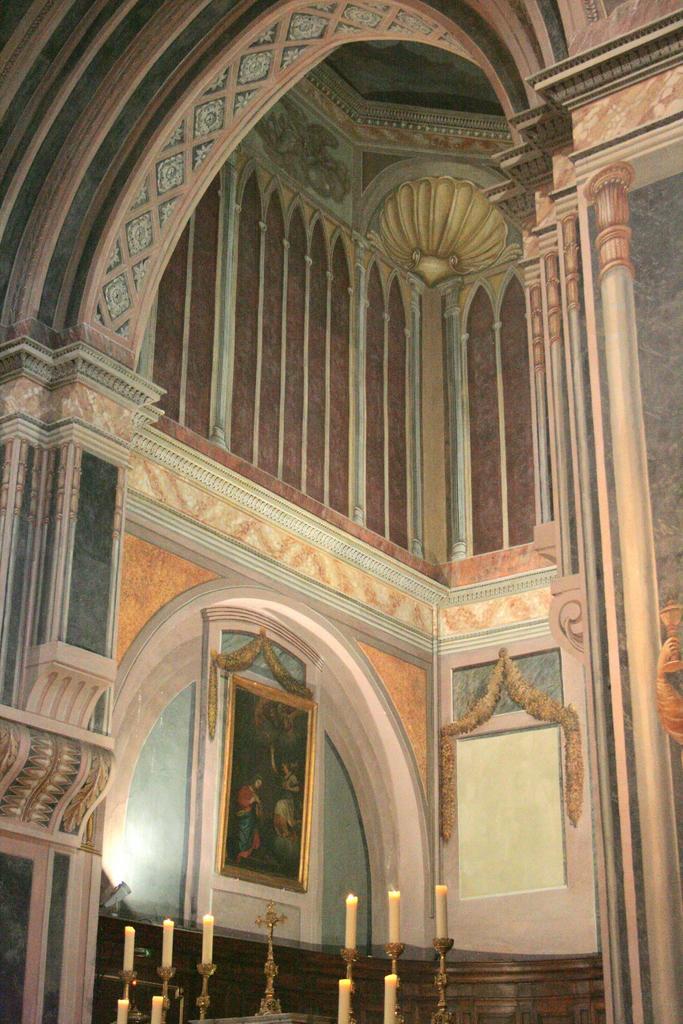How would you summarize this image in a sentence or two? In front of the image there are candles and a cross, behind that there are photo frames on the wall. 